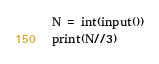<code> <loc_0><loc_0><loc_500><loc_500><_Python_>N = int(input())
print(N//3)</code> 